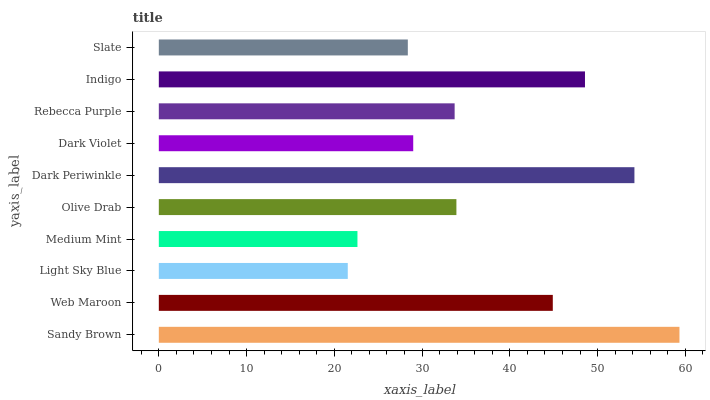Is Light Sky Blue the minimum?
Answer yes or no. Yes. Is Sandy Brown the maximum?
Answer yes or no. Yes. Is Web Maroon the minimum?
Answer yes or no. No. Is Web Maroon the maximum?
Answer yes or no. No. Is Sandy Brown greater than Web Maroon?
Answer yes or no. Yes. Is Web Maroon less than Sandy Brown?
Answer yes or no. Yes. Is Web Maroon greater than Sandy Brown?
Answer yes or no. No. Is Sandy Brown less than Web Maroon?
Answer yes or no. No. Is Olive Drab the high median?
Answer yes or no. Yes. Is Rebecca Purple the low median?
Answer yes or no. Yes. Is Web Maroon the high median?
Answer yes or no. No. Is Indigo the low median?
Answer yes or no. No. 